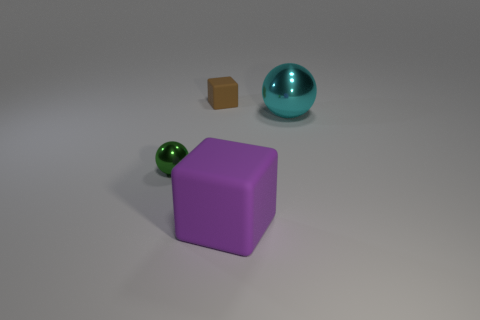What shape is the other thing that is the same size as the green thing?
Make the answer very short. Cube. How many other objects are there of the same color as the large rubber object?
Give a very brief answer. 0. What number of other objects are there of the same material as the large purple object?
Make the answer very short. 1. There is a brown matte cube; is it the same size as the ball that is right of the green shiny sphere?
Offer a very short reply. No. What color is the small ball?
Keep it short and to the point. Green. What is the shape of the thing that is left of the matte object that is behind the block that is in front of the small brown matte block?
Your answer should be very brief. Sphere. What material is the ball in front of the big object behind the purple matte cube?
Provide a short and direct response. Metal. There is a large object that is made of the same material as the tiny sphere; what shape is it?
Provide a short and direct response. Sphere. Are there any other things that have the same shape as the purple matte thing?
Give a very brief answer. Yes. What number of objects are behind the purple rubber cube?
Keep it short and to the point. 3. 